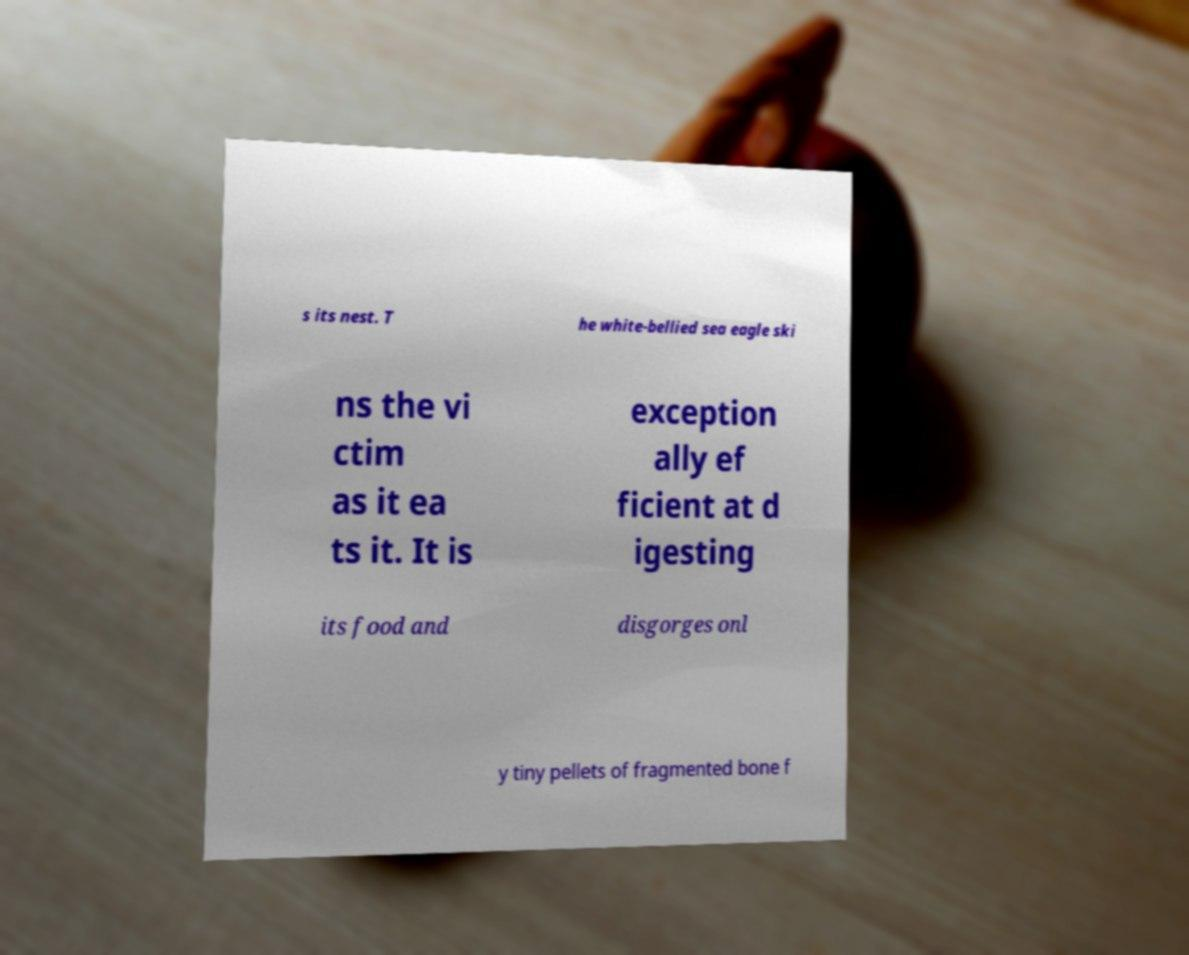What messages or text are displayed in this image? I need them in a readable, typed format. s its nest. T he white-bellied sea eagle ski ns the vi ctim as it ea ts it. It is exception ally ef ficient at d igesting its food and disgorges onl y tiny pellets of fragmented bone f 